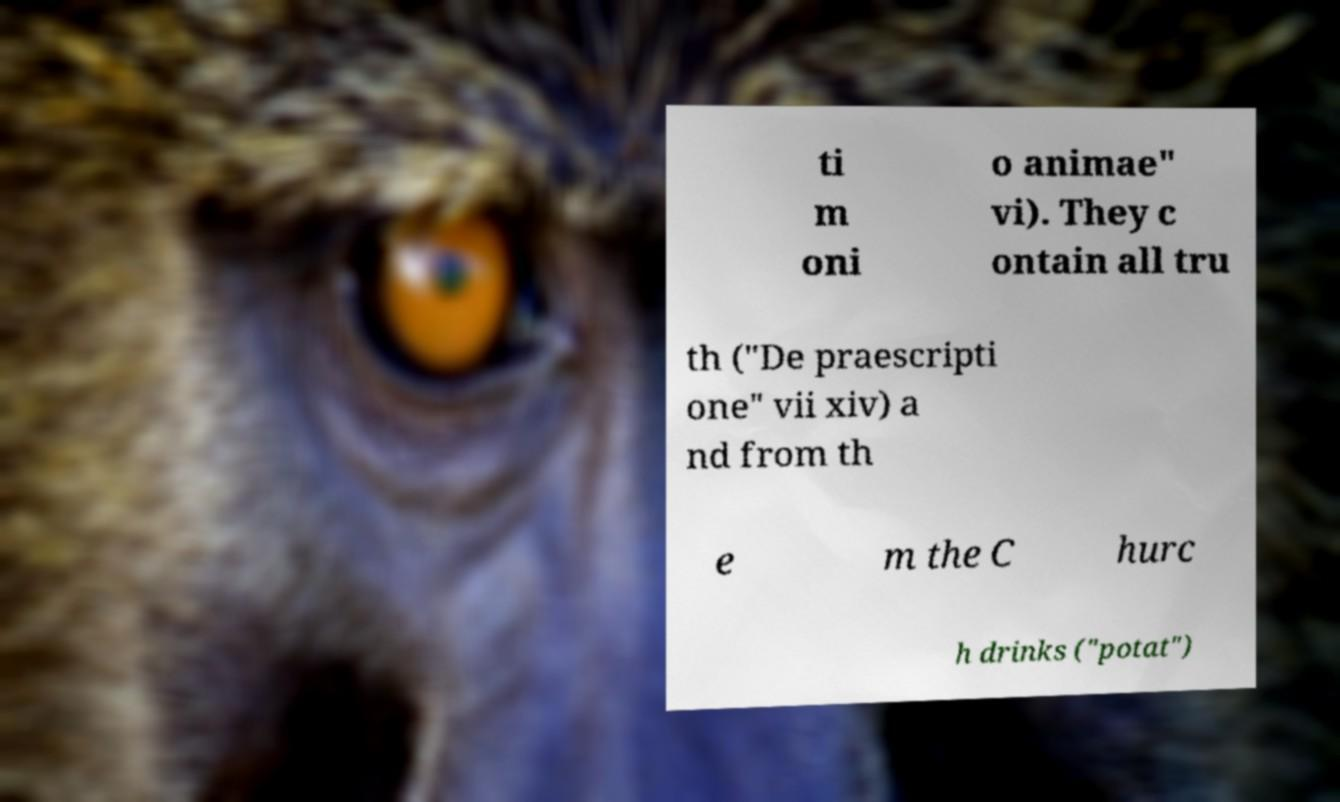Could you extract and type out the text from this image? ti m oni o animae" vi). They c ontain all tru th ("De praescripti one" vii xiv) a nd from th e m the C hurc h drinks ("potat") 